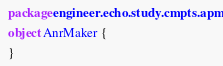<code> <loc_0><loc_0><loc_500><loc_500><_Kotlin_>package engineer.echo.study.cmpts.apm

object AnrMaker {

}</code> 